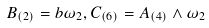<formula> <loc_0><loc_0><loc_500><loc_500>B _ { ( 2 ) } = b \omega _ { 2 } , C _ { ( 6 ) } = A _ { ( 4 ) } \wedge \omega _ { 2 }</formula> 